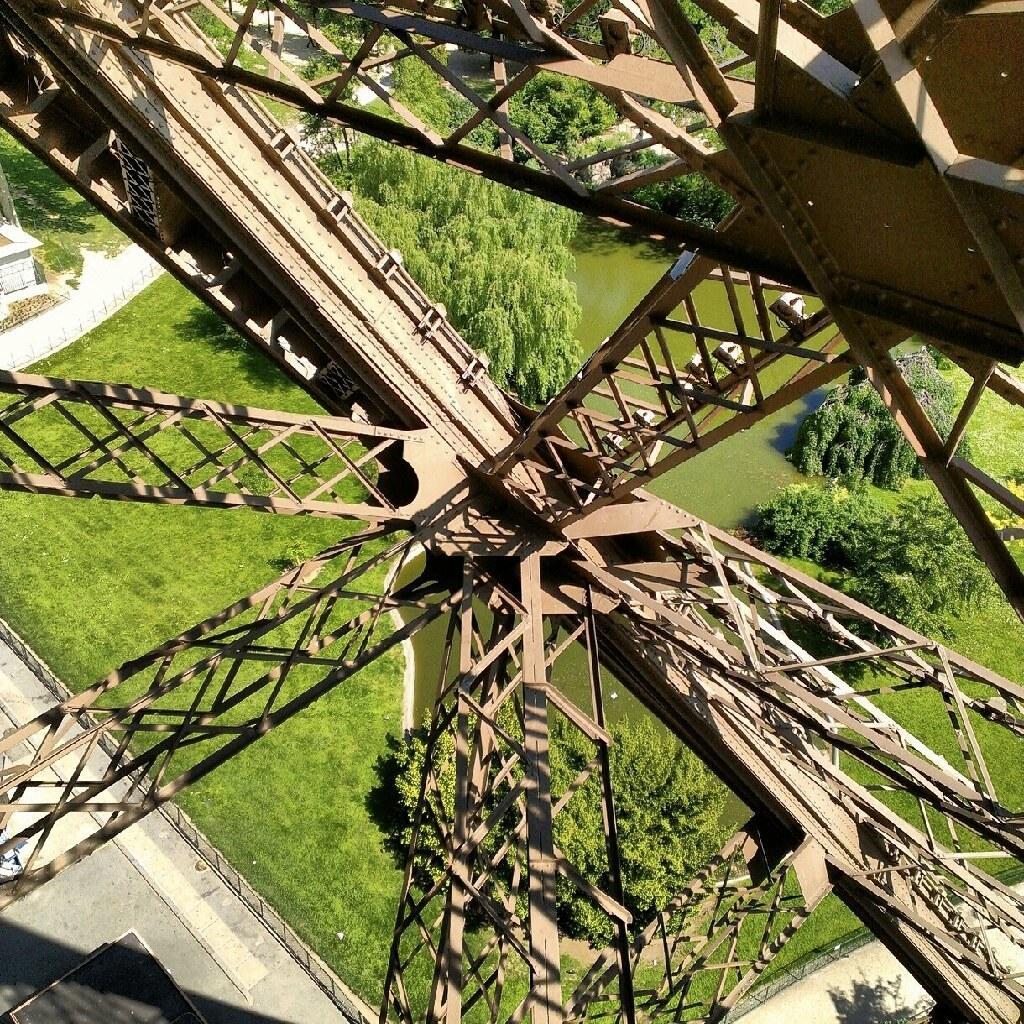Can you describe this image briefly? In this image we can see the iron rods. And at the bottom we can see the trees, grass and water. 